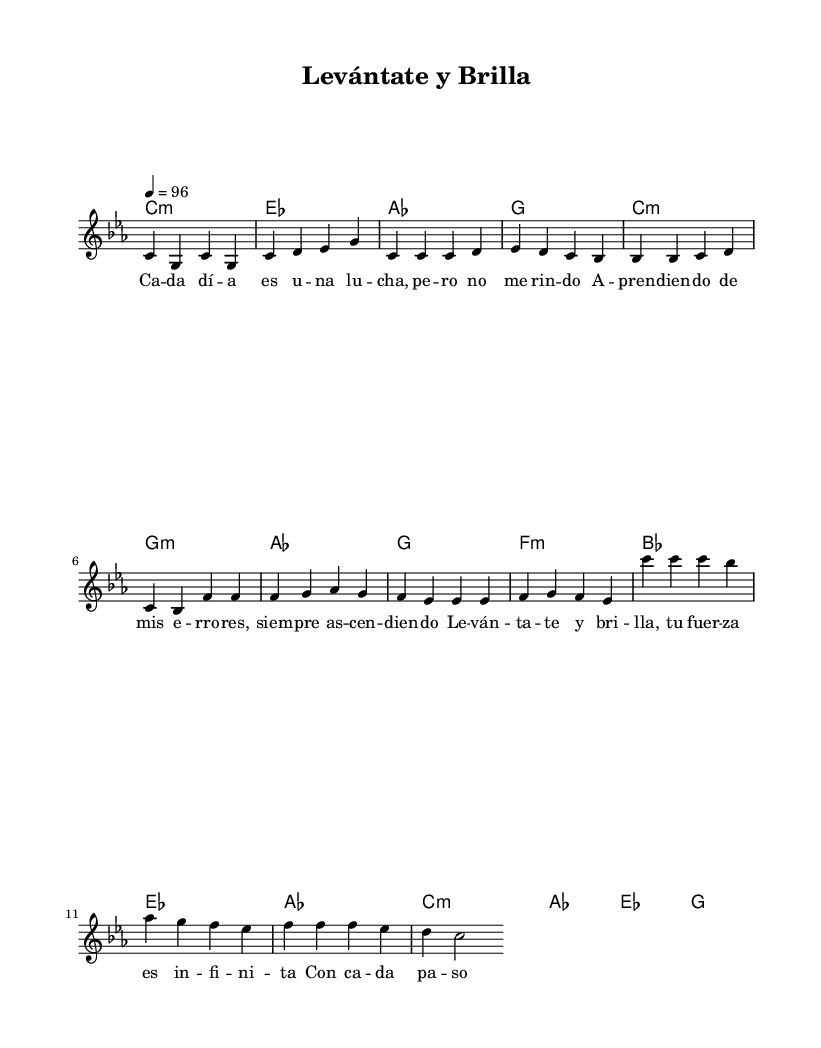What is the key signature of this music? The key signature is C minor, which has three flats (B flat, E flat, and A flat). This can be identified by looking at the notation at the beginning of the score where the key is indicated.
Answer: C minor What is the time signature of this music? The time signature is 4/4, which means there are four beats in each measure and the quarter note gets one beat. This can be seen at the beginning of the score where the time signature is noted.
Answer: 4/4 What is the tempo marking of this piece? The tempo marking is quarter note equals 96 beats per minute. This indicates the speed of the music, as found near the beginning of the score.
Answer: 96 What is the mood conveyed in the chorus section? The mood is uplifting and empowering, as reflected in the lyrics urging to "Levántate y brilla," which means "Get up and shine." This can be deduced from the positive wording in the chorus lyrics.
Answer: Uplifting How many measures are in the verse section? There are eight measures in the verse section, as it is evident by counting the distinct bars notated in the verse part of the music.
Answer: Eight Which musical element is repeated in the pre-chorus? The note F is repeated multiple times in the pre-chorus section, creating a sense of emphasis and building momentum. This is determined by analyzing the melody line where F appears consecutively.
Answer: F What is the overall theme reflected through this sheet music? The overall theme is resilience and self-improvement, which is encapsulated in the lyrics and repeated encouragement to rise and shine. This is understood by examining the lyrics and their motivational context.
Answer: Resilience 